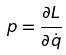Convert formula to latex. <formula><loc_0><loc_0><loc_500><loc_500>p = \frac { \partial L } { \partial \dot { q } }</formula> 